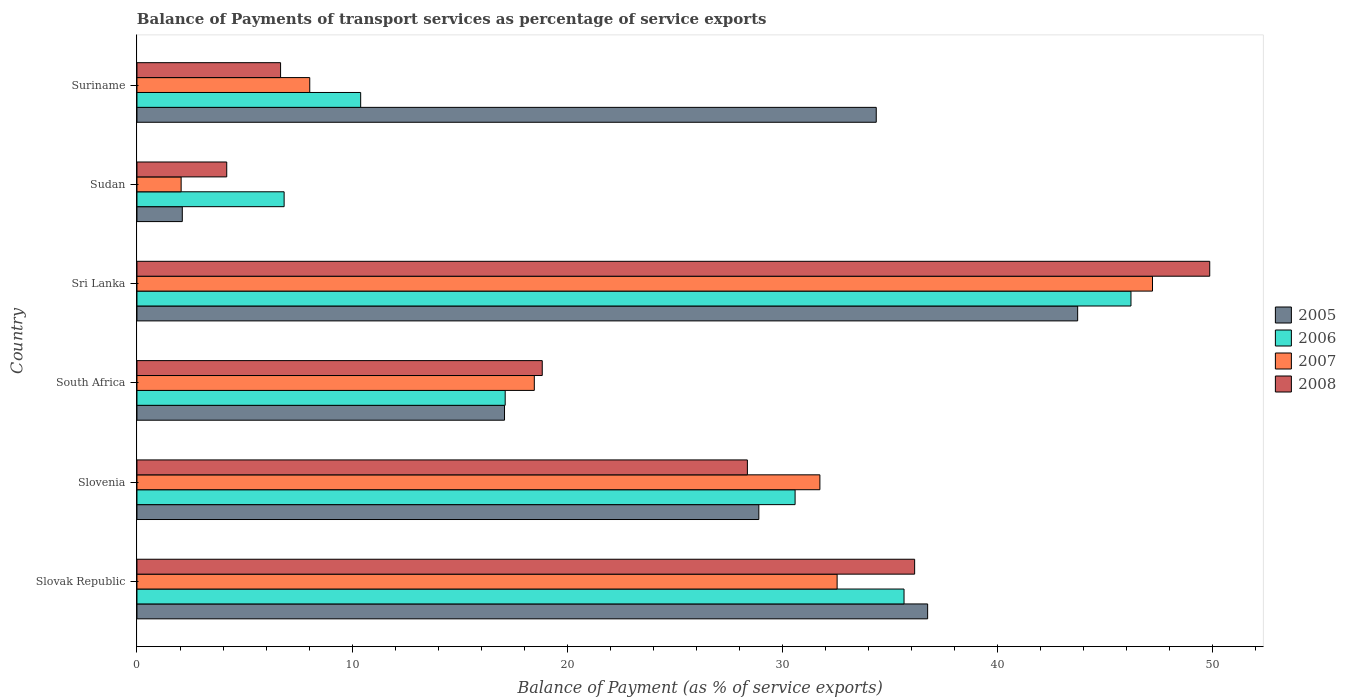How many different coloured bars are there?
Give a very brief answer. 4. How many groups of bars are there?
Give a very brief answer. 6. Are the number of bars per tick equal to the number of legend labels?
Offer a very short reply. Yes. What is the label of the 5th group of bars from the top?
Offer a very short reply. Slovenia. What is the balance of payments of transport services in 2005 in Sri Lanka?
Your response must be concise. 43.72. Across all countries, what is the maximum balance of payments of transport services in 2006?
Ensure brevity in your answer.  46.2. Across all countries, what is the minimum balance of payments of transport services in 2006?
Your response must be concise. 6.84. In which country was the balance of payments of transport services in 2008 maximum?
Provide a succinct answer. Sri Lanka. In which country was the balance of payments of transport services in 2008 minimum?
Make the answer very short. Sudan. What is the total balance of payments of transport services in 2006 in the graph?
Your answer should be very brief. 146.79. What is the difference between the balance of payments of transport services in 2006 in Sri Lanka and that in Suriname?
Offer a very short reply. 35.8. What is the difference between the balance of payments of transport services in 2006 in Sudan and the balance of payments of transport services in 2008 in South Africa?
Keep it short and to the point. -12. What is the average balance of payments of transport services in 2007 per country?
Your answer should be compact. 23.34. What is the difference between the balance of payments of transport services in 2006 and balance of payments of transport services in 2007 in Suriname?
Your response must be concise. 2.37. In how many countries, is the balance of payments of transport services in 2006 greater than 18 %?
Make the answer very short. 3. What is the ratio of the balance of payments of transport services in 2007 in Slovenia to that in Suriname?
Provide a short and direct response. 3.95. Is the difference between the balance of payments of transport services in 2006 in Slovak Republic and Sudan greater than the difference between the balance of payments of transport services in 2007 in Slovak Republic and Sudan?
Make the answer very short. No. What is the difference between the highest and the second highest balance of payments of transport services in 2006?
Keep it short and to the point. 10.55. What is the difference between the highest and the lowest balance of payments of transport services in 2006?
Keep it short and to the point. 39.36. In how many countries, is the balance of payments of transport services in 2007 greater than the average balance of payments of transport services in 2007 taken over all countries?
Your answer should be compact. 3. Is it the case that in every country, the sum of the balance of payments of transport services in 2007 and balance of payments of transport services in 2006 is greater than the sum of balance of payments of transport services in 2008 and balance of payments of transport services in 2005?
Ensure brevity in your answer.  No. What does the 1st bar from the top in Slovak Republic represents?
Offer a very short reply. 2008. What does the 3rd bar from the bottom in Suriname represents?
Give a very brief answer. 2007. Is it the case that in every country, the sum of the balance of payments of transport services in 2007 and balance of payments of transport services in 2006 is greater than the balance of payments of transport services in 2008?
Keep it short and to the point. Yes. What is the difference between two consecutive major ticks on the X-axis?
Provide a short and direct response. 10. Where does the legend appear in the graph?
Keep it short and to the point. Center right. How are the legend labels stacked?
Offer a very short reply. Vertical. What is the title of the graph?
Ensure brevity in your answer.  Balance of Payments of transport services as percentage of service exports. Does "2005" appear as one of the legend labels in the graph?
Give a very brief answer. Yes. What is the label or title of the X-axis?
Provide a short and direct response. Balance of Payment (as % of service exports). What is the Balance of Payment (as % of service exports) in 2005 in Slovak Republic?
Make the answer very short. 36.75. What is the Balance of Payment (as % of service exports) of 2006 in Slovak Republic?
Offer a terse response. 35.65. What is the Balance of Payment (as % of service exports) of 2007 in Slovak Republic?
Your answer should be compact. 32.54. What is the Balance of Payment (as % of service exports) in 2008 in Slovak Republic?
Provide a succinct answer. 36.14. What is the Balance of Payment (as % of service exports) in 2005 in Slovenia?
Offer a terse response. 28.9. What is the Balance of Payment (as % of service exports) of 2006 in Slovenia?
Provide a short and direct response. 30.59. What is the Balance of Payment (as % of service exports) in 2007 in Slovenia?
Make the answer very short. 31.74. What is the Balance of Payment (as % of service exports) in 2008 in Slovenia?
Provide a short and direct response. 28.37. What is the Balance of Payment (as % of service exports) in 2005 in South Africa?
Provide a short and direct response. 17.08. What is the Balance of Payment (as % of service exports) in 2006 in South Africa?
Ensure brevity in your answer.  17.11. What is the Balance of Payment (as % of service exports) of 2007 in South Africa?
Make the answer very short. 18.47. What is the Balance of Payment (as % of service exports) in 2008 in South Africa?
Give a very brief answer. 18.84. What is the Balance of Payment (as % of service exports) in 2005 in Sri Lanka?
Keep it short and to the point. 43.72. What is the Balance of Payment (as % of service exports) in 2006 in Sri Lanka?
Offer a terse response. 46.2. What is the Balance of Payment (as % of service exports) in 2007 in Sri Lanka?
Keep it short and to the point. 47.2. What is the Balance of Payment (as % of service exports) of 2008 in Sri Lanka?
Your response must be concise. 49.86. What is the Balance of Payment (as % of service exports) in 2005 in Sudan?
Offer a terse response. 2.11. What is the Balance of Payment (as % of service exports) in 2006 in Sudan?
Give a very brief answer. 6.84. What is the Balance of Payment (as % of service exports) of 2007 in Sudan?
Provide a short and direct response. 2.05. What is the Balance of Payment (as % of service exports) of 2008 in Sudan?
Your response must be concise. 4.17. What is the Balance of Payment (as % of service exports) of 2005 in Suriname?
Your response must be concise. 34.36. What is the Balance of Payment (as % of service exports) in 2006 in Suriname?
Offer a very short reply. 10.4. What is the Balance of Payment (as % of service exports) in 2007 in Suriname?
Give a very brief answer. 8.03. What is the Balance of Payment (as % of service exports) in 2008 in Suriname?
Your response must be concise. 6.67. Across all countries, what is the maximum Balance of Payment (as % of service exports) of 2005?
Your answer should be compact. 43.72. Across all countries, what is the maximum Balance of Payment (as % of service exports) in 2006?
Provide a short and direct response. 46.2. Across all countries, what is the maximum Balance of Payment (as % of service exports) in 2007?
Provide a short and direct response. 47.2. Across all countries, what is the maximum Balance of Payment (as % of service exports) of 2008?
Your answer should be very brief. 49.86. Across all countries, what is the minimum Balance of Payment (as % of service exports) of 2005?
Keep it short and to the point. 2.11. Across all countries, what is the minimum Balance of Payment (as % of service exports) in 2006?
Your response must be concise. 6.84. Across all countries, what is the minimum Balance of Payment (as % of service exports) of 2007?
Provide a succinct answer. 2.05. Across all countries, what is the minimum Balance of Payment (as % of service exports) of 2008?
Provide a succinct answer. 4.17. What is the total Balance of Payment (as % of service exports) of 2005 in the graph?
Offer a terse response. 162.93. What is the total Balance of Payment (as % of service exports) in 2006 in the graph?
Offer a very short reply. 146.79. What is the total Balance of Payment (as % of service exports) in 2007 in the graph?
Offer a terse response. 140.04. What is the total Balance of Payment (as % of service exports) of 2008 in the graph?
Provide a short and direct response. 144.06. What is the difference between the Balance of Payment (as % of service exports) in 2005 in Slovak Republic and that in Slovenia?
Offer a very short reply. 7.85. What is the difference between the Balance of Payment (as % of service exports) in 2006 in Slovak Republic and that in Slovenia?
Offer a terse response. 5.06. What is the difference between the Balance of Payment (as % of service exports) in 2007 in Slovak Republic and that in Slovenia?
Make the answer very short. 0.8. What is the difference between the Balance of Payment (as % of service exports) of 2008 in Slovak Republic and that in Slovenia?
Your response must be concise. 7.77. What is the difference between the Balance of Payment (as % of service exports) of 2005 in Slovak Republic and that in South Africa?
Your answer should be compact. 19.67. What is the difference between the Balance of Payment (as % of service exports) of 2006 in Slovak Republic and that in South Africa?
Offer a very short reply. 18.54. What is the difference between the Balance of Payment (as % of service exports) in 2007 in Slovak Republic and that in South Africa?
Your response must be concise. 14.07. What is the difference between the Balance of Payment (as % of service exports) of 2008 in Slovak Republic and that in South Africa?
Your answer should be compact. 17.31. What is the difference between the Balance of Payment (as % of service exports) in 2005 in Slovak Republic and that in Sri Lanka?
Your answer should be compact. -6.97. What is the difference between the Balance of Payment (as % of service exports) in 2006 in Slovak Republic and that in Sri Lanka?
Ensure brevity in your answer.  -10.55. What is the difference between the Balance of Payment (as % of service exports) in 2007 in Slovak Republic and that in Sri Lanka?
Provide a short and direct response. -14.66. What is the difference between the Balance of Payment (as % of service exports) in 2008 in Slovak Republic and that in Sri Lanka?
Make the answer very short. -13.72. What is the difference between the Balance of Payment (as % of service exports) in 2005 in Slovak Republic and that in Sudan?
Offer a very short reply. 34.64. What is the difference between the Balance of Payment (as % of service exports) in 2006 in Slovak Republic and that in Sudan?
Your response must be concise. 28.81. What is the difference between the Balance of Payment (as % of service exports) in 2007 in Slovak Republic and that in Sudan?
Your response must be concise. 30.49. What is the difference between the Balance of Payment (as % of service exports) in 2008 in Slovak Republic and that in Sudan?
Provide a short and direct response. 31.97. What is the difference between the Balance of Payment (as % of service exports) of 2005 in Slovak Republic and that in Suriname?
Your answer should be compact. 2.39. What is the difference between the Balance of Payment (as % of service exports) in 2006 in Slovak Republic and that in Suriname?
Your response must be concise. 25.25. What is the difference between the Balance of Payment (as % of service exports) of 2007 in Slovak Republic and that in Suriname?
Give a very brief answer. 24.51. What is the difference between the Balance of Payment (as % of service exports) in 2008 in Slovak Republic and that in Suriname?
Make the answer very short. 29.47. What is the difference between the Balance of Payment (as % of service exports) of 2005 in Slovenia and that in South Africa?
Keep it short and to the point. 11.82. What is the difference between the Balance of Payment (as % of service exports) of 2006 in Slovenia and that in South Africa?
Make the answer very short. 13.47. What is the difference between the Balance of Payment (as % of service exports) in 2007 in Slovenia and that in South Africa?
Your answer should be very brief. 13.27. What is the difference between the Balance of Payment (as % of service exports) in 2008 in Slovenia and that in South Africa?
Your answer should be compact. 9.53. What is the difference between the Balance of Payment (as % of service exports) in 2005 in Slovenia and that in Sri Lanka?
Give a very brief answer. -14.82. What is the difference between the Balance of Payment (as % of service exports) of 2006 in Slovenia and that in Sri Lanka?
Keep it short and to the point. -15.61. What is the difference between the Balance of Payment (as % of service exports) in 2007 in Slovenia and that in Sri Lanka?
Keep it short and to the point. -15.46. What is the difference between the Balance of Payment (as % of service exports) in 2008 in Slovenia and that in Sri Lanka?
Give a very brief answer. -21.49. What is the difference between the Balance of Payment (as % of service exports) of 2005 in Slovenia and that in Sudan?
Your response must be concise. 26.8. What is the difference between the Balance of Payment (as % of service exports) in 2006 in Slovenia and that in Sudan?
Your answer should be very brief. 23.75. What is the difference between the Balance of Payment (as % of service exports) of 2007 in Slovenia and that in Sudan?
Ensure brevity in your answer.  29.69. What is the difference between the Balance of Payment (as % of service exports) in 2008 in Slovenia and that in Sudan?
Offer a very short reply. 24.2. What is the difference between the Balance of Payment (as % of service exports) of 2005 in Slovenia and that in Suriname?
Offer a terse response. -5.46. What is the difference between the Balance of Payment (as % of service exports) in 2006 in Slovenia and that in Suriname?
Give a very brief answer. 20.19. What is the difference between the Balance of Payment (as % of service exports) in 2007 in Slovenia and that in Suriname?
Provide a short and direct response. 23.71. What is the difference between the Balance of Payment (as % of service exports) in 2008 in Slovenia and that in Suriname?
Provide a short and direct response. 21.7. What is the difference between the Balance of Payment (as % of service exports) in 2005 in South Africa and that in Sri Lanka?
Make the answer very short. -26.64. What is the difference between the Balance of Payment (as % of service exports) in 2006 in South Africa and that in Sri Lanka?
Give a very brief answer. -29.09. What is the difference between the Balance of Payment (as % of service exports) in 2007 in South Africa and that in Sri Lanka?
Offer a terse response. -28.73. What is the difference between the Balance of Payment (as % of service exports) of 2008 in South Africa and that in Sri Lanka?
Your answer should be very brief. -31.02. What is the difference between the Balance of Payment (as % of service exports) of 2005 in South Africa and that in Sudan?
Your response must be concise. 14.98. What is the difference between the Balance of Payment (as % of service exports) in 2006 in South Africa and that in Sudan?
Your answer should be compact. 10.27. What is the difference between the Balance of Payment (as % of service exports) in 2007 in South Africa and that in Sudan?
Give a very brief answer. 16.41. What is the difference between the Balance of Payment (as % of service exports) of 2008 in South Africa and that in Sudan?
Keep it short and to the point. 14.66. What is the difference between the Balance of Payment (as % of service exports) of 2005 in South Africa and that in Suriname?
Your answer should be very brief. -17.28. What is the difference between the Balance of Payment (as % of service exports) of 2006 in South Africa and that in Suriname?
Your answer should be very brief. 6.72. What is the difference between the Balance of Payment (as % of service exports) of 2007 in South Africa and that in Suriname?
Provide a short and direct response. 10.44. What is the difference between the Balance of Payment (as % of service exports) of 2008 in South Africa and that in Suriname?
Give a very brief answer. 12.16. What is the difference between the Balance of Payment (as % of service exports) in 2005 in Sri Lanka and that in Sudan?
Ensure brevity in your answer.  41.61. What is the difference between the Balance of Payment (as % of service exports) in 2006 in Sri Lanka and that in Sudan?
Your answer should be compact. 39.36. What is the difference between the Balance of Payment (as % of service exports) of 2007 in Sri Lanka and that in Sudan?
Provide a succinct answer. 45.15. What is the difference between the Balance of Payment (as % of service exports) of 2008 in Sri Lanka and that in Sudan?
Give a very brief answer. 45.69. What is the difference between the Balance of Payment (as % of service exports) in 2005 in Sri Lanka and that in Suriname?
Your answer should be very brief. 9.36. What is the difference between the Balance of Payment (as % of service exports) of 2006 in Sri Lanka and that in Suriname?
Keep it short and to the point. 35.8. What is the difference between the Balance of Payment (as % of service exports) in 2007 in Sri Lanka and that in Suriname?
Give a very brief answer. 39.17. What is the difference between the Balance of Payment (as % of service exports) in 2008 in Sri Lanka and that in Suriname?
Give a very brief answer. 43.19. What is the difference between the Balance of Payment (as % of service exports) in 2005 in Sudan and that in Suriname?
Your answer should be very brief. -32.25. What is the difference between the Balance of Payment (as % of service exports) in 2006 in Sudan and that in Suriname?
Offer a very short reply. -3.56. What is the difference between the Balance of Payment (as % of service exports) of 2007 in Sudan and that in Suriname?
Your response must be concise. -5.98. What is the difference between the Balance of Payment (as % of service exports) of 2008 in Sudan and that in Suriname?
Make the answer very short. -2.5. What is the difference between the Balance of Payment (as % of service exports) of 2005 in Slovak Republic and the Balance of Payment (as % of service exports) of 2006 in Slovenia?
Your response must be concise. 6.16. What is the difference between the Balance of Payment (as % of service exports) of 2005 in Slovak Republic and the Balance of Payment (as % of service exports) of 2007 in Slovenia?
Provide a succinct answer. 5.01. What is the difference between the Balance of Payment (as % of service exports) in 2005 in Slovak Republic and the Balance of Payment (as % of service exports) in 2008 in Slovenia?
Your answer should be compact. 8.38. What is the difference between the Balance of Payment (as % of service exports) of 2006 in Slovak Republic and the Balance of Payment (as % of service exports) of 2007 in Slovenia?
Your answer should be very brief. 3.91. What is the difference between the Balance of Payment (as % of service exports) of 2006 in Slovak Republic and the Balance of Payment (as % of service exports) of 2008 in Slovenia?
Your response must be concise. 7.28. What is the difference between the Balance of Payment (as % of service exports) in 2007 in Slovak Republic and the Balance of Payment (as % of service exports) in 2008 in Slovenia?
Ensure brevity in your answer.  4.17. What is the difference between the Balance of Payment (as % of service exports) in 2005 in Slovak Republic and the Balance of Payment (as % of service exports) in 2006 in South Africa?
Keep it short and to the point. 19.64. What is the difference between the Balance of Payment (as % of service exports) of 2005 in Slovak Republic and the Balance of Payment (as % of service exports) of 2007 in South Africa?
Offer a very short reply. 18.28. What is the difference between the Balance of Payment (as % of service exports) of 2005 in Slovak Republic and the Balance of Payment (as % of service exports) of 2008 in South Africa?
Make the answer very short. 17.91. What is the difference between the Balance of Payment (as % of service exports) of 2006 in Slovak Republic and the Balance of Payment (as % of service exports) of 2007 in South Africa?
Make the answer very short. 17.18. What is the difference between the Balance of Payment (as % of service exports) in 2006 in Slovak Republic and the Balance of Payment (as % of service exports) in 2008 in South Africa?
Offer a terse response. 16.81. What is the difference between the Balance of Payment (as % of service exports) of 2007 in Slovak Republic and the Balance of Payment (as % of service exports) of 2008 in South Africa?
Your answer should be compact. 13.71. What is the difference between the Balance of Payment (as % of service exports) of 2005 in Slovak Republic and the Balance of Payment (as % of service exports) of 2006 in Sri Lanka?
Make the answer very short. -9.45. What is the difference between the Balance of Payment (as % of service exports) of 2005 in Slovak Republic and the Balance of Payment (as % of service exports) of 2007 in Sri Lanka?
Your answer should be compact. -10.45. What is the difference between the Balance of Payment (as % of service exports) of 2005 in Slovak Republic and the Balance of Payment (as % of service exports) of 2008 in Sri Lanka?
Your response must be concise. -13.11. What is the difference between the Balance of Payment (as % of service exports) of 2006 in Slovak Republic and the Balance of Payment (as % of service exports) of 2007 in Sri Lanka?
Provide a succinct answer. -11.55. What is the difference between the Balance of Payment (as % of service exports) in 2006 in Slovak Republic and the Balance of Payment (as % of service exports) in 2008 in Sri Lanka?
Provide a short and direct response. -14.21. What is the difference between the Balance of Payment (as % of service exports) in 2007 in Slovak Republic and the Balance of Payment (as % of service exports) in 2008 in Sri Lanka?
Ensure brevity in your answer.  -17.32. What is the difference between the Balance of Payment (as % of service exports) of 2005 in Slovak Republic and the Balance of Payment (as % of service exports) of 2006 in Sudan?
Keep it short and to the point. 29.91. What is the difference between the Balance of Payment (as % of service exports) of 2005 in Slovak Republic and the Balance of Payment (as % of service exports) of 2007 in Sudan?
Offer a terse response. 34.7. What is the difference between the Balance of Payment (as % of service exports) in 2005 in Slovak Republic and the Balance of Payment (as % of service exports) in 2008 in Sudan?
Your response must be concise. 32.58. What is the difference between the Balance of Payment (as % of service exports) of 2006 in Slovak Republic and the Balance of Payment (as % of service exports) of 2007 in Sudan?
Offer a terse response. 33.6. What is the difference between the Balance of Payment (as % of service exports) of 2006 in Slovak Republic and the Balance of Payment (as % of service exports) of 2008 in Sudan?
Ensure brevity in your answer.  31.48. What is the difference between the Balance of Payment (as % of service exports) of 2007 in Slovak Republic and the Balance of Payment (as % of service exports) of 2008 in Sudan?
Your answer should be compact. 28.37. What is the difference between the Balance of Payment (as % of service exports) in 2005 in Slovak Republic and the Balance of Payment (as % of service exports) in 2006 in Suriname?
Provide a succinct answer. 26.35. What is the difference between the Balance of Payment (as % of service exports) of 2005 in Slovak Republic and the Balance of Payment (as % of service exports) of 2007 in Suriname?
Your answer should be very brief. 28.72. What is the difference between the Balance of Payment (as % of service exports) of 2005 in Slovak Republic and the Balance of Payment (as % of service exports) of 2008 in Suriname?
Ensure brevity in your answer.  30.07. What is the difference between the Balance of Payment (as % of service exports) in 2006 in Slovak Republic and the Balance of Payment (as % of service exports) in 2007 in Suriname?
Ensure brevity in your answer.  27.62. What is the difference between the Balance of Payment (as % of service exports) in 2006 in Slovak Republic and the Balance of Payment (as % of service exports) in 2008 in Suriname?
Offer a very short reply. 28.98. What is the difference between the Balance of Payment (as % of service exports) in 2007 in Slovak Republic and the Balance of Payment (as % of service exports) in 2008 in Suriname?
Make the answer very short. 25.87. What is the difference between the Balance of Payment (as % of service exports) of 2005 in Slovenia and the Balance of Payment (as % of service exports) of 2006 in South Africa?
Provide a succinct answer. 11.79. What is the difference between the Balance of Payment (as % of service exports) of 2005 in Slovenia and the Balance of Payment (as % of service exports) of 2007 in South Africa?
Offer a terse response. 10.44. What is the difference between the Balance of Payment (as % of service exports) in 2005 in Slovenia and the Balance of Payment (as % of service exports) in 2008 in South Africa?
Provide a succinct answer. 10.07. What is the difference between the Balance of Payment (as % of service exports) in 2006 in Slovenia and the Balance of Payment (as % of service exports) in 2007 in South Africa?
Make the answer very short. 12.12. What is the difference between the Balance of Payment (as % of service exports) of 2006 in Slovenia and the Balance of Payment (as % of service exports) of 2008 in South Africa?
Your answer should be very brief. 11.75. What is the difference between the Balance of Payment (as % of service exports) of 2007 in Slovenia and the Balance of Payment (as % of service exports) of 2008 in South Africa?
Your answer should be compact. 12.9. What is the difference between the Balance of Payment (as % of service exports) in 2005 in Slovenia and the Balance of Payment (as % of service exports) in 2006 in Sri Lanka?
Provide a succinct answer. -17.3. What is the difference between the Balance of Payment (as % of service exports) in 2005 in Slovenia and the Balance of Payment (as % of service exports) in 2007 in Sri Lanka?
Your response must be concise. -18.3. What is the difference between the Balance of Payment (as % of service exports) of 2005 in Slovenia and the Balance of Payment (as % of service exports) of 2008 in Sri Lanka?
Make the answer very short. -20.96. What is the difference between the Balance of Payment (as % of service exports) in 2006 in Slovenia and the Balance of Payment (as % of service exports) in 2007 in Sri Lanka?
Offer a terse response. -16.61. What is the difference between the Balance of Payment (as % of service exports) of 2006 in Slovenia and the Balance of Payment (as % of service exports) of 2008 in Sri Lanka?
Your answer should be compact. -19.27. What is the difference between the Balance of Payment (as % of service exports) of 2007 in Slovenia and the Balance of Payment (as % of service exports) of 2008 in Sri Lanka?
Ensure brevity in your answer.  -18.12. What is the difference between the Balance of Payment (as % of service exports) in 2005 in Slovenia and the Balance of Payment (as % of service exports) in 2006 in Sudan?
Offer a very short reply. 22.06. What is the difference between the Balance of Payment (as % of service exports) in 2005 in Slovenia and the Balance of Payment (as % of service exports) in 2007 in Sudan?
Your response must be concise. 26.85. What is the difference between the Balance of Payment (as % of service exports) of 2005 in Slovenia and the Balance of Payment (as % of service exports) of 2008 in Sudan?
Provide a succinct answer. 24.73. What is the difference between the Balance of Payment (as % of service exports) in 2006 in Slovenia and the Balance of Payment (as % of service exports) in 2007 in Sudan?
Offer a terse response. 28.54. What is the difference between the Balance of Payment (as % of service exports) in 2006 in Slovenia and the Balance of Payment (as % of service exports) in 2008 in Sudan?
Your response must be concise. 26.42. What is the difference between the Balance of Payment (as % of service exports) of 2007 in Slovenia and the Balance of Payment (as % of service exports) of 2008 in Sudan?
Provide a short and direct response. 27.57. What is the difference between the Balance of Payment (as % of service exports) of 2005 in Slovenia and the Balance of Payment (as % of service exports) of 2006 in Suriname?
Keep it short and to the point. 18.51. What is the difference between the Balance of Payment (as % of service exports) in 2005 in Slovenia and the Balance of Payment (as % of service exports) in 2007 in Suriname?
Keep it short and to the point. 20.87. What is the difference between the Balance of Payment (as % of service exports) of 2005 in Slovenia and the Balance of Payment (as % of service exports) of 2008 in Suriname?
Your answer should be very brief. 22.23. What is the difference between the Balance of Payment (as % of service exports) in 2006 in Slovenia and the Balance of Payment (as % of service exports) in 2007 in Suriname?
Your answer should be compact. 22.56. What is the difference between the Balance of Payment (as % of service exports) of 2006 in Slovenia and the Balance of Payment (as % of service exports) of 2008 in Suriname?
Your answer should be compact. 23.91. What is the difference between the Balance of Payment (as % of service exports) of 2007 in Slovenia and the Balance of Payment (as % of service exports) of 2008 in Suriname?
Offer a terse response. 25.07. What is the difference between the Balance of Payment (as % of service exports) of 2005 in South Africa and the Balance of Payment (as % of service exports) of 2006 in Sri Lanka?
Make the answer very short. -29.12. What is the difference between the Balance of Payment (as % of service exports) of 2005 in South Africa and the Balance of Payment (as % of service exports) of 2007 in Sri Lanka?
Provide a short and direct response. -30.12. What is the difference between the Balance of Payment (as % of service exports) in 2005 in South Africa and the Balance of Payment (as % of service exports) in 2008 in Sri Lanka?
Provide a succinct answer. -32.78. What is the difference between the Balance of Payment (as % of service exports) of 2006 in South Africa and the Balance of Payment (as % of service exports) of 2007 in Sri Lanka?
Your answer should be very brief. -30.09. What is the difference between the Balance of Payment (as % of service exports) of 2006 in South Africa and the Balance of Payment (as % of service exports) of 2008 in Sri Lanka?
Give a very brief answer. -32.75. What is the difference between the Balance of Payment (as % of service exports) of 2007 in South Africa and the Balance of Payment (as % of service exports) of 2008 in Sri Lanka?
Make the answer very short. -31.39. What is the difference between the Balance of Payment (as % of service exports) in 2005 in South Africa and the Balance of Payment (as % of service exports) in 2006 in Sudan?
Your answer should be compact. 10.24. What is the difference between the Balance of Payment (as % of service exports) in 2005 in South Africa and the Balance of Payment (as % of service exports) in 2007 in Sudan?
Offer a very short reply. 15.03. What is the difference between the Balance of Payment (as % of service exports) in 2005 in South Africa and the Balance of Payment (as % of service exports) in 2008 in Sudan?
Provide a succinct answer. 12.91. What is the difference between the Balance of Payment (as % of service exports) of 2006 in South Africa and the Balance of Payment (as % of service exports) of 2007 in Sudan?
Offer a terse response. 15.06. What is the difference between the Balance of Payment (as % of service exports) in 2006 in South Africa and the Balance of Payment (as % of service exports) in 2008 in Sudan?
Provide a succinct answer. 12.94. What is the difference between the Balance of Payment (as % of service exports) in 2007 in South Africa and the Balance of Payment (as % of service exports) in 2008 in Sudan?
Ensure brevity in your answer.  14.3. What is the difference between the Balance of Payment (as % of service exports) of 2005 in South Africa and the Balance of Payment (as % of service exports) of 2006 in Suriname?
Provide a succinct answer. 6.69. What is the difference between the Balance of Payment (as % of service exports) in 2005 in South Africa and the Balance of Payment (as % of service exports) in 2007 in Suriname?
Provide a succinct answer. 9.05. What is the difference between the Balance of Payment (as % of service exports) of 2005 in South Africa and the Balance of Payment (as % of service exports) of 2008 in Suriname?
Your response must be concise. 10.41. What is the difference between the Balance of Payment (as % of service exports) in 2006 in South Africa and the Balance of Payment (as % of service exports) in 2007 in Suriname?
Your response must be concise. 9.08. What is the difference between the Balance of Payment (as % of service exports) in 2006 in South Africa and the Balance of Payment (as % of service exports) in 2008 in Suriname?
Your answer should be very brief. 10.44. What is the difference between the Balance of Payment (as % of service exports) of 2007 in South Africa and the Balance of Payment (as % of service exports) of 2008 in Suriname?
Ensure brevity in your answer.  11.79. What is the difference between the Balance of Payment (as % of service exports) of 2005 in Sri Lanka and the Balance of Payment (as % of service exports) of 2006 in Sudan?
Your answer should be very brief. 36.88. What is the difference between the Balance of Payment (as % of service exports) in 2005 in Sri Lanka and the Balance of Payment (as % of service exports) in 2007 in Sudan?
Your answer should be very brief. 41.67. What is the difference between the Balance of Payment (as % of service exports) in 2005 in Sri Lanka and the Balance of Payment (as % of service exports) in 2008 in Sudan?
Offer a terse response. 39.55. What is the difference between the Balance of Payment (as % of service exports) of 2006 in Sri Lanka and the Balance of Payment (as % of service exports) of 2007 in Sudan?
Make the answer very short. 44.15. What is the difference between the Balance of Payment (as % of service exports) in 2006 in Sri Lanka and the Balance of Payment (as % of service exports) in 2008 in Sudan?
Provide a short and direct response. 42.03. What is the difference between the Balance of Payment (as % of service exports) of 2007 in Sri Lanka and the Balance of Payment (as % of service exports) of 2008 in Sudan?
Your answer should be compact. 43.03. What is the difference between the Balance of Payment (as % of service exports) in 2005 in Sri Lanka and the Balance of Payment (as % of service exports) in 2006 in Suriname?
Your answer should be very brief. 33.32. What is the difference between the Balance of Payment (as % of service exports) in 2005 in Sri Lanka and the Balance of Payment (as % of service exports) in 2007 in Suriname?
Provide a succinct answer. 35.69. What is the difference between the Balance of Payment (as % of service exports) in 2005 in Sri Lanka and the Balance of Payment (as % of service exports) in 2008 in Suriname?
Offer a terse response. 37.05. What is the difference between the Balance of Payment (as % of service exports) of 2006 in Sri Lanka and the Balance of Payment (as % of service exports) of 2007 in Suriname?
Keep it short and to the point. 38.17. What is the difference between the Balance of Payment (as % of service exports) in 2006 in Sri Lanka and the Balance of Payment (as % of service exports) in 2008 in Suriname?
Your answer should be compact. 39.52. What is the difference between the Balance of Payment (as % of service exports) in 2007 in Sri Lanka and the Balance of Payment (as % of service exports) in 2008 in Suriname?
Make the answer very short. 40.53. What is the difference between the Balance of Payment (as % of service exports) in 2005 in Sudan and the Balance of Payment (as % of service exports) in 2006 in Suriname?
Keep it short and to the point. -8.29. What is the difference between the Balance of Payment (as % of service exports) in 2005 in Sudan and the Balance of Payment (as % of service exports) in 2007 in Suriname?
Provide a succinct answer. -5.92. What is the difference between the Balance of Payment (as % of service exports) of 2005 in Sudan and the Balance of Payment (as % of service exports) of 2008 in Suriname?
Your response must be concise. -4.57. What is the difference between the Balance of Payment (as % of service exports) in 2006 in Sudan and the Balance of Payment (as % of service exports) in 2007 in Suriname?
Provide a short and direct response. -1.19. What is the difference between the Balance of Payment (as % of service exports) in 2006 in Sudan and the Balance of Payment (as % of service exports) in 2008 in Suriname?
Your answer should be compact. 0.17. What is the difference between the Balance of Payment (as % of service exports) in 2007 in Sudan and the Balance of Payment (as % of service exports) in 2008 in Suriname?
Your response must be concise. -4.62. What is the average Balance of Payment (as % of service exports) of 2005 per country?
Your answer should be compact. 27.15. What is the average Balance of Payment (as % of service exports) of 2006 per country?
Your answer should be compact. 24.47. What is the average Balance of Payment (as % of service exports) of 2007 per country?
Offer a very short reply. 23.34. What is the average Balance of Payment (as % of service exports) in 2008 per country?
Give a very brief answer. 24.01. What is the difference between the Balance of Payment (as % of service exports) in 2005 and Balance of Payment (as % of service exports) in 2006 in Slovak Republic?
Your answer should be very brief. 1.1. What is the difference between the Balance of Payment (as % of service exports) of 2005 and Balance of Payment (as % of service exports) of 2007 in Slovak Republic?
Your answer should be compact. 4.21. What is the difference between the Balance of Payment (as % of service exports) of 2005 and Balance of Payment (as % of service exports) of 2008 in Slovak Republic?
Provide a short and direct response. 0.6. What is the difference between the Balance of Payment (as % of service exports) in 2006 and Balance of Payment (as % of service exports) in 2007 in Slovak Republic?
Ensure brevity in your answer.  3.11. What is the difference between the Balance of Payment (as % of service exports) in 2006 and Balance of Payment (as % of service exports) in 2008 in Slovak Republic?
Provide a short and direct response. -0.49. What is the difference between the Balance of Payment (as % of service exports) of 2007 and Balance of Payment (as % of service exports) of 2008 in Slovak Republic?
Keep it short and to the point. -3.6. What is the difference between the Balance of Payment (as % of service exports) in 2005 and Balance of Payment (as % of service exports) in 2006 in Slovenia?
Provide a short and direct response. -1.69. What is the difference between the Balance of Payment (as % of service exports) in 2005 and Balance of Payment (as % of service exports) in 2007 in Slovenia?
Keep it short and to the point. -2.84. What is the difference between the Balance of Payment (as % of service exports) of 2005 and Balance of Payment (as % of service exports) of 2008 in Slovenia?
Offer a very short reply. 0.53. What is the difference between the Balance of Payment (as % of service exports) of 2006 and Balance of Payment (as % of service exports) of 2007 in Slovenia?
Ensure brevity in your answer.  -1.15. What is the difference between the Balance of Payment (as % of service exports) of 2006 and Balance of Payment (as % of service exports) of 2008 in Slovenia?
Offer a very short reply. 2.22. What is the difference between the Balance of Payment (as % of service exports) of 2007 and Balance of Payment (as % of service exports) of 2008 in Slovenia?
Provide a succinct answer. 3.37. What is the difference between the Balance of Payment (as % of service exports) in 2005 and Balance of Payment (as % of service exports) in 2006 in South Africa?
Keep it short and to the point. -0.03. What is the difference between the Balance of Payment (as % of service exports) in 2005 and Balance of Payment (as % of service exports) in 2007 in South Africa?
Keep it short and to the point. -1.38. What is the difference between the Balance of Payment (as % of service exports) in 2005 and Balance of Payment (as % of service exports) in 2008 in South Africa?
Provide a short and direct response. -1.75. What is the difference between the Balance of Payment (as % of service exports) of 2006 and Balance of Payment (as % of service exports) of 2007 in South Africa?
Give a very brief answer. -1.35. What is the difference between the Balance of Payment (as % of service exports) of 2006 and Balance of Payment (as % of service exports) of 2008 in South Africa?
Your answer should be very brief. -1.72. What is the difference between the Balance of Payment (as % of service exports) in 2007 and Balance of Payment (as % of service exports) in 2008 in South Africa?
Your answer should be very brief. -0.37. What is the difference between the Balance of Payment (as % of service exports) in 2005 and Balance of Payment (as % of service exports) in 2006 in Sri Lanka?
Your response must be concise. -2.48. What is the difference between the Balance of Payment (as % of service exports) in 2005 and Balance of Payment (as % of service exports) in 2007 in Sri Lanka?
Provide a short and direct response. -3.48. What is the difference between the Balance of Payment (as % of service exports) in 2005 and Balance of Payment (as % of service exports) in 2008 in Sri Lanka?
Provide a short and direct response. -6.14. What is the difference between the Balance of Payment (as % of service exports) of 2006 and Balance of Payment (as % of service exports) of 2007 in Sri Lanka?
Your answer should be very brief. -1. What is the difference between the Balance of Payment (as % of service exports) in 2006 and Balance of Payment (as % of service exports) in 2008 in Sri Lanka?
Your answer should be very brief. -3.66. What is the difference between the Balance of Payment (as % of service exports) in 2007 and Balance of Payment (as % of service exports) in 2008 in Sri Lanka?
Keep it short and to the point. -2.66. What is the difference between the Balance of Payment (as % of service exports) of 2005 and Balance of Payment (as % of service exports) of 2006 in Sudan?
Offer a terse response. -4.73. What is the difference between the Balance of Payment (as % of service exports) in 2005 and Balance of Payment (as % of service exports) in 2007 in Sudan?
Your answer should be very brief. 0.05. What is the difference between the Balance of Payment (as % of service exports) of 2005 and Balance of Payment (as % of service exports) of 2008 in Sudan?
Your answer should be very brief. -2.07. What is the difference between the Balance of Payment (as % of service exports) in 2006 and Balance of Payment (as % of service exports) in 2007 in Sudan?
Keep it short and to the point. 4.79. What is the difference between the Balance of Payment (as % of service exports) of 2006 and Balance of Payment (as % of service exports) of 2008 in Sudan?
Offer a very short reply. 2.67. What is the difference between the Balance of Payment (as % of service exports) of 2007 and Balance of Payment (as % of service exports) of 2008 in Sudan?
Make the answer very short. -2.12. What is the difference between the Balance of Payment (as % of service exports) of 2005 and Balance of Payment (as % of service exports) of 2006 in Suriname?
Your answer should be very brief. 23.96. What is the difference between the Balance of Payment (as % of service exports) in 2005 and Balance of Payment (as % of service exports) in 2007 in Suriname?
Provide a short and direct response. 26.33. What is the difference between the Balance of Payment (as % of service exports) in 2005 and Balance of Payment (as % of service exports) in 2008 in Suriname?
Ensure brevity in your answer.  27.69. What is the difference between the Balance of Payment (as % of service exports) of 2006 and Balance of Payment (as % of service exports) of 2007 in Suriname?
Make the answer very short. 2.37. What is the difference between the Balance of Payment (as % of service exports) of 2006 and Balance of Payment (as % of service exports) of 2008 in Suriname?
Offer a terse response. 3.72. What is the difference between the Balance of Payment (as % of service exports) of 2007 and Balance of Payment (as % of service exports) of 2008 in Suriname?
Your response must be concise. 1.36. What is the ratio of the Balance of Payment (as % of service exports) of 2005 in Slovak Republic to that in Slovenia?
Ensure brevity in your answer.  1.27. What is the ratio of the Balance of Payment (as % of service exports) of 2006 in Slovak Republic to that in Slovenia?
Provide a succinct answer. 1.17. What is the ratio of the Balance of Payment (as % of service exports) of 2007 in Slovak Republic to that in Slovenia?
Offer a very short reply. 1.03. What is the ratio of the Balance of Payment (as % of service exports) of 2008 in Slovak Republic to that in Slovenia?
Offer a very short reply. 1.27. What is the ratio of the Balance of Payment (as % of service exports) in 2005 in Slovak Republic to that in South Africa?
Give a very brief answer. 2.15. What is the ratio of the Balance of Payment (as % of service exports) of 2006 in Slovak Republic to that in South Africa?
Provide a succinct answer. 2.08. What is the ratio of the Balance of Payment (as % of service exports) in 2007 in Slovak Republic to that in South Africa?
Ensure brevity in your answer.  1.76. What is the ratio of the Balance of Payment (as % of service exports) of 2008 in Slovak Republic to that in South Africa?
Your response must be concise. 1.92. What is the ratio of the Balance of Payment (as % of service exports) of 2005 in Slovak Republic to that in Sri Lanka?
Provide a succinct answer. 0.84. What is the ratio of the Balance of Payment (as % of service exports) in 2006 in Slovak Republic to that in Sri Lanka?
Offer a terse response. 0.77. What is the ratio of the Balance of Payment (as % of service exports) of 2007 in Slovak Republic to that in Sri Lanka?
Your response must be concise. 0.69. What is the ratio of the Balance of Payment (as % of service exports) in 2008 in Slovak Republic to that in Sri Lanka?
Keep it short and to the point. 0.72. What is the ratio of the Balance of Payment (as % of service exports) of 2005 in Slovak Republic to that in Sudan?
Provide a short and direct response. 17.44. What is the ratio of the Balance of Payment (as % of service exports) in 2006 in Slovak Republic to that in Sudan?
Ensure brevity in your answer.  5.21. What is the ratio of the Balance of Payment (as % of service exports) of 2007 in Slovak Republic to that in Sudan?
Make the answer very short. 15.85. What is the ratio of the Balance of Payment (as % of service exports) in 2008 in Slovak Republic to that in Sudan?
Provide a succinct answer. 8.66. What is the ratio of the Balance of Payment (as % of service exports) of 2005 in Slovak Republic to that in Suriname?
Your response must be concise. 1.07. What is the ratio of the Balance of Payment (as % of service exports) of 2006 in Slovak Republic to that in Suriname?
Keep it short and to the point. 3.43. What is the ratio of the Balance of Payment (as % of service exports) in 2007 in Slovak Republic to that in Suriname?
Provide a succinct answer. 4.05. What is the ratio of the Balance of Payment (as % of service exports) of 2008 in Slovak Republic to that in Suriname?
Your answer should be compact. 5.42. What is the ratio of the Balance of Payment (as % of service exports) in 2005 in Slovenia to that in South Africa?
Ensure brevity in your answer.  1.69. What is the ratio of the Balance of Payment (as % of service exports) of 2006 in Slovenia to that in South Africa?
Your answer should be compact. 1.79. What is the ratio of the Balance of Payment (as % of service exports) in 2007 in Slovenia to that in South Africa?
Your answer should be compact. 1.72. What is the ratio of the Balance of Payment (as % of service exports) in 2008 in Slovenia to that in South Africa?
Your answer should be compact. 1.51. What is the ratio of the Balance of Payment (as % of service exports) in 2005 in Slovenia to that in Sri Lanka?
Offer a terse response. 0.66. What is the ratio of the Balance of Payment (as % of service exports) in 2006 in Slovenia to that in Sri Lanka?
Provide a short and direct response. 0.66. What is the ratio of the Balance of Payment (as % of service exports) in 2007 in Slovenia to that in Sri Lanka?
Make the answer very short. 0.67. What is the ratio of the Balance of Payment (as % of service exports) of 2008 in Slovenia to that in Sri Lanka?
Your answer should be compact. 0.57. What is the ratio of the Balance of Payment (as % of service exports) of 2005 in Slovenia to that in Sudan?
Provide a succinct answer. 13.72. What is the ratio of the Balance of Payment (as % of service exports) in 2006 in Slovenia to that in Sudan?
Ensure brevity in your answer.  4.47. What is the ratio of the Balance of Payment (as % of service exports) in 2007 in Slovenia to that in Sudan?
Keep it short and to the point. 15.46. What is the ratio of the Balance of Payment (as % of service exports) in 2008 in Slovenia to that in Sudan?
Ensure brevity in your answer.  6.8. What is the ratio of the Balance of Payment (as % of service exports) of 2005 in Slovenia to that in Suriname?
Your answer should be compact. 0.84. What is the ratio of the Balance of Payment (as % of service exports) in 2006 in Slovenia to that in Suriname?
Give a very brief answer. 2.94. What is the ratio of the Balance of Payment (as % of service exports) of 2007 in Slovenia to that in Suriname?
Your answer should be very brief. 3.95. What is the ratio of the Balance of Payment (as % of service exports) of 2008 in Slovenia to that in Suriname?
Offer a very short reply. 4.25. What is the ratio of the Balance of Payment (as % of service exports) of 2005 in South Africa to that in Sri Lanka?
Your response must be concise. 0.39. What is the ratio of the Balance of Payment (as % of service exports) in 2006 in South Africa to that in Sri Lanka?
Keep it short and to the point. 0.37. What is the ratio of the Balance of Payment (as % of service exports) in 2007 in South Africa to that in Sri Lanka?
Your response must be concise. 0.39. What is the ratio of the Balance of Payment (as % of service exports) in 2008 in South Africa to that in Sri Lanka?
Make the answer very short. 0.38. What is the ratio of the Balance of Payment (as % of service exports) in 2005 in South Africa to that in Sudan?
Offer a very short reply. 8.11. What is the ratio of the Balance of Payment (as % of service exports) in 2006 in South Africa to that in Sudan?
Provide a succinct answer. 2.5. What is the ratio of the Balance of Payment (as % of service exports) of 2007 in South Africa to that in Sudan?
Ensure brevity in your answer.  8.99. What is the ratio of the Balance of Payment (as % of service exports) in 2008 in South Africa to that in Sudan?
Offer a very short reply. 4.51. What is the ratio of the Balance of Payment (as % of service exports) in 2005 in South Africa to that in Suriname?
Offer a terse response. 0.5. What is the ratio of the Balance of Payment (as % of service exports) of 2006 in South Africa to that in Suriname?
Offer a terse response. 1.65. What is the ratio of the Balance of Payment (as % of service exports) of 2007 in South Africa to that in Suriname?
Your answer should be compact. 2.3. What is the ratio of the Balance of Payment (as % of service exports) of 2008 in South Africa to that in Suriname?
Make the answer very short. 2.82. What is the ratio of the Balance of Payment (as % of service exports) in 2005 in Sri Lanka to that in Sudan?
Offer a terse response. 20.75. What is the ratio of the Balance of Payment (as % of service exports) of 2006 in Sri Lanka to that in Sudan?
Give a very brief answer. 6.75. What is the ratio of the Balance of Payment (as % of service exports) of 2007 in Sri Lanka to that in Sudan?
Your answer should be compact. 22.99. What is the ratio of the Balance of Payment (as % of service exports) of 2008 in Sri Lanka to that in Sudan?
Provide a succinct answer. 11.95. What is the ratio of the Balance of Payment (as % of service exports) in 2005 in Sri Lanka to that in Suriname?
Offer a terse response. 1.27. What is the ratio of the Balance of Payment (as % of service exports) of 2006 in Sri Lanka to that in Suriname?
Your response must be concise. 4.44. What is the ratio of the Balance of Payment (as % of service exports) in 2007 in Sri Lanka to that in Suriname?
Give a very brief answer. 5.88. What is the ratio of the Balance of Payment (as % of service exports) of 2008 in Sri Lanka to that in Suriname?
Keep it short and to the point. 7.47. What is the ratio of the Balance of Payment (as % of service exports) in 2005 in Sudan to that in Suriname?
Make the answer very short. 0.06. What is the ratio of the Balance of Payment (as % of service exports) of 2006 in Sudan to that in Suriname?
Provide a succinct answer. 0.66. What is the ratio of the Balance of Payment (as % of service exports) in 2007 in Sudan to that in Suriname?
Provide a short and direct response. 0.26. What is the ratio of the Balance of Payment (as % of service exports) of 2008 in Sudan to that in Suriname?
Provide a succinct answer. 0.63. What is the difference between the highest and the second highest Balance of Payment (as % of service exports) of 2005?
Ensure brevity in your answer.  6.97. What is the difference between the highest and the second highest Balance of Payment (as % of service exports) in 2006?
Offer a terse response. 10.55. What is the difference between the highest and the second highest Balance of Payment (as % of service exports) in 2007?
Ensure brevity in your answer.  14.66. What is the difference between the highest and the second highest Balance of Payment (as % of service exports) in 2008?
Provide a short and direct response. 13.72. What is the difference between the highest and the lowest Balance of Payment (as % of service exports) of 2005?
Your answer should be very brief. 41.61. What is the difference between the highest and the lowest Balance of Payment (as % of service exports) of 2006?
Give a very brief answer. 39.36. What is the difference between the highest and the lowest Balance of Payment (as % of service exports) of 2007?
Your answer should be very brief. 45.15. What is the difference between the highest and the lowest Balance of Payment (as % of service exports) in 2008?
Your response must be concise. 45.69. 